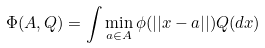<formula> <loc_0><loc_0><loc_500><loc_500>\Phi ( A , Q ) = \int \min _ { a \in A } \phi ( | | x - a | | ) Q ( d x )</formula> 